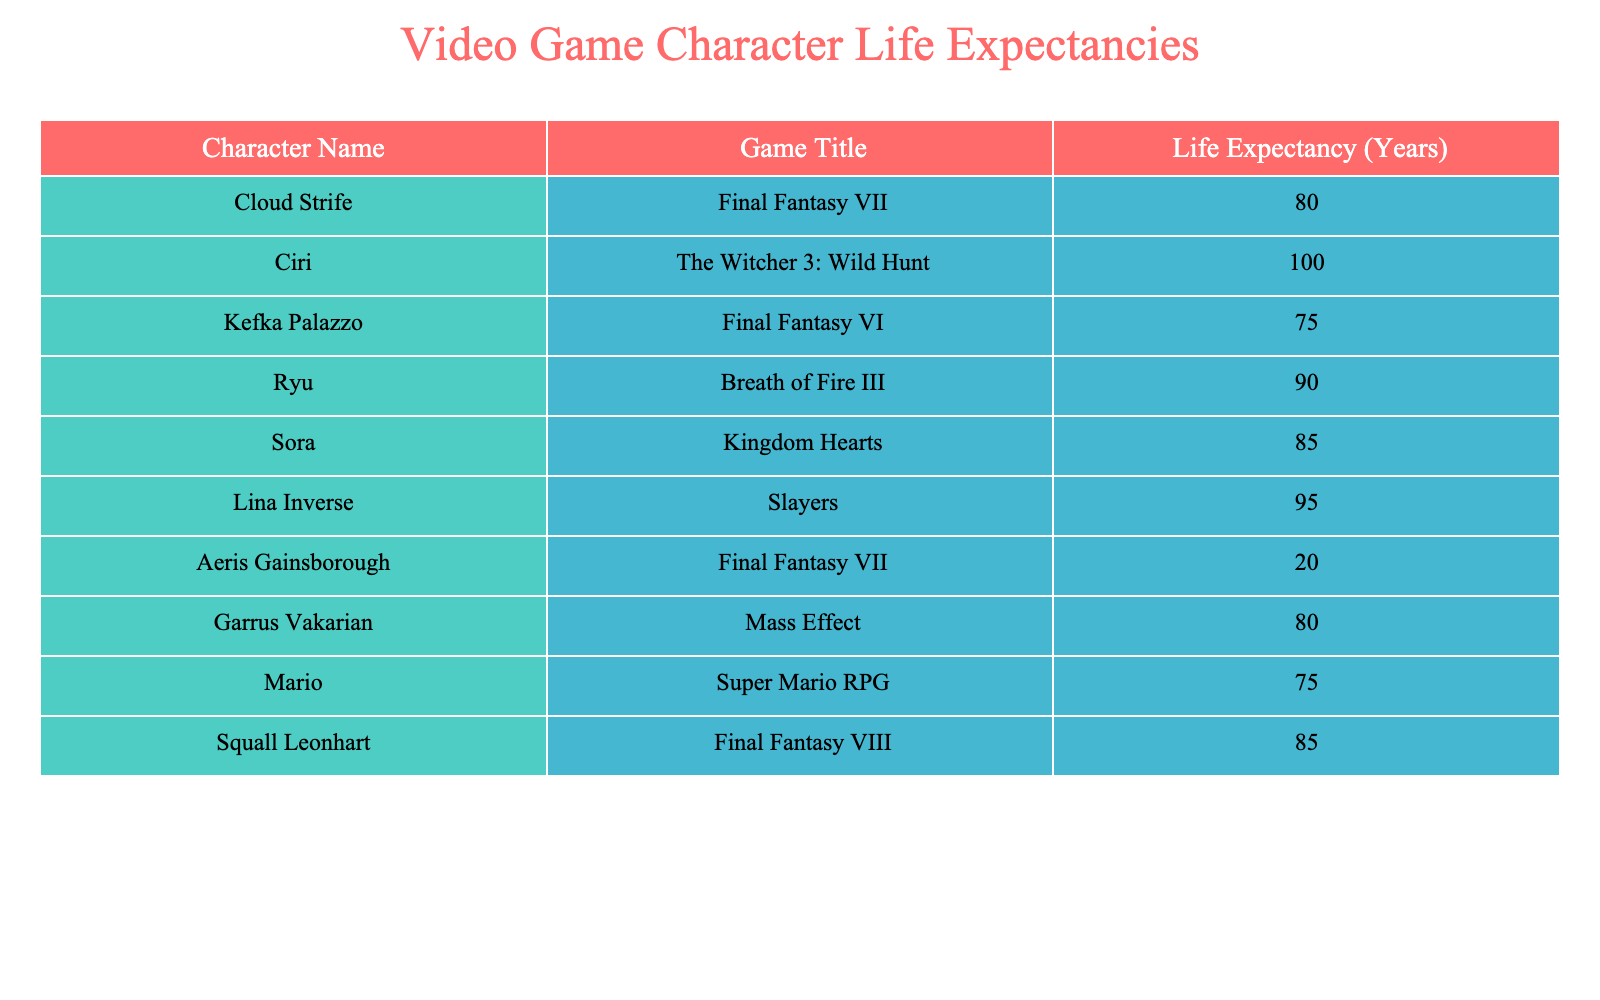What is the life expectancy of Ciri? Ciri's life expectancy is directly listed under her name in the table.
Answer: 100 Which character has the lowest life expectancy? By scanning through the life expectancy column, Aeris Gainsborough has the lowest life expectancy at 20 years.
Answer: 20 What is the average life expectancy of the characters from Final Fantasy games? The characters from Final Fantasy are Cloud Strife (80), Kefka Palazzo (75), Aeris Gainsborough (20), Squall Leonhart (85), and assuming there are 4 characters from Final Fantasy. Their total life expectancy is (80 + 75 + 20 + 85) = 260. The average is 260 / 4 = 65.
Answer: 65 Is Sora's life expectancy greater than Ryu's? Sora's life expectancy is 85 years and Ryu's is 90 years, making Sora's less than Ryu's.
Answer: No What is the combined life expectancy of Mario and Kefka Palazzo? We find Mario's life expectancy (75) and Kefka's (75), then sum them up: 75 + 75 = 150.
Answer: 150 What is the life expectancy of characters from games that have a life expectancy of over 80 years? The characters with life expectancies over 80 years are Ciri (100), Ryu (90), Lina Inverse (95), and Sora (85). Their life expectancies are listed and filtered accordingly.
Answer: 100, 90, 95, 85 Which character had a life expectancy of 80 years? By checking through the table, both Cloud Strife and Garrus Vakarian are listed with a life expectancy of 80 years.
Answer: Cloud Strife and Garrus Vakarian What is the difference in life expectancy between Squall Leonhart and Kefka Palazzo? Squall Leonhart has a life expectancy of 85 years and Kefka Palazzo has 75 years. The difference is calculated as 85 - 75 = 10 years.
Answer: 10 Which character has a life expectancy greater than 90 years? When checking the table, Ciri is the only character that exceeds 90 years with an expectancy of 100.
Answer: Yes 